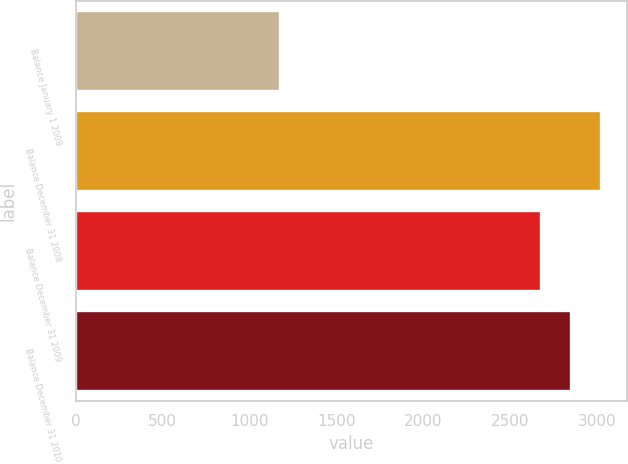Convert chart to OTSL. <chart><loc_0><loc_0><loc_500><loc_500><bar_chart><fcel>Balance January 1 2008<fcel>Balance December 31 2008<fcel>Balance December 31 2009<fcel>Balance December 31 2010<nl><fcel>1173<fcel>3019.6<fcel>2674<fcel>2846.8<nl></chart> 